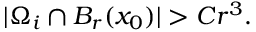<formula> <loc_0><loc_0><loc_500><loc_500>| \Omega _ { i } \cap B _ { r } ( x _ { 0 } ) | > C r ^ { 3 } .</formula> 